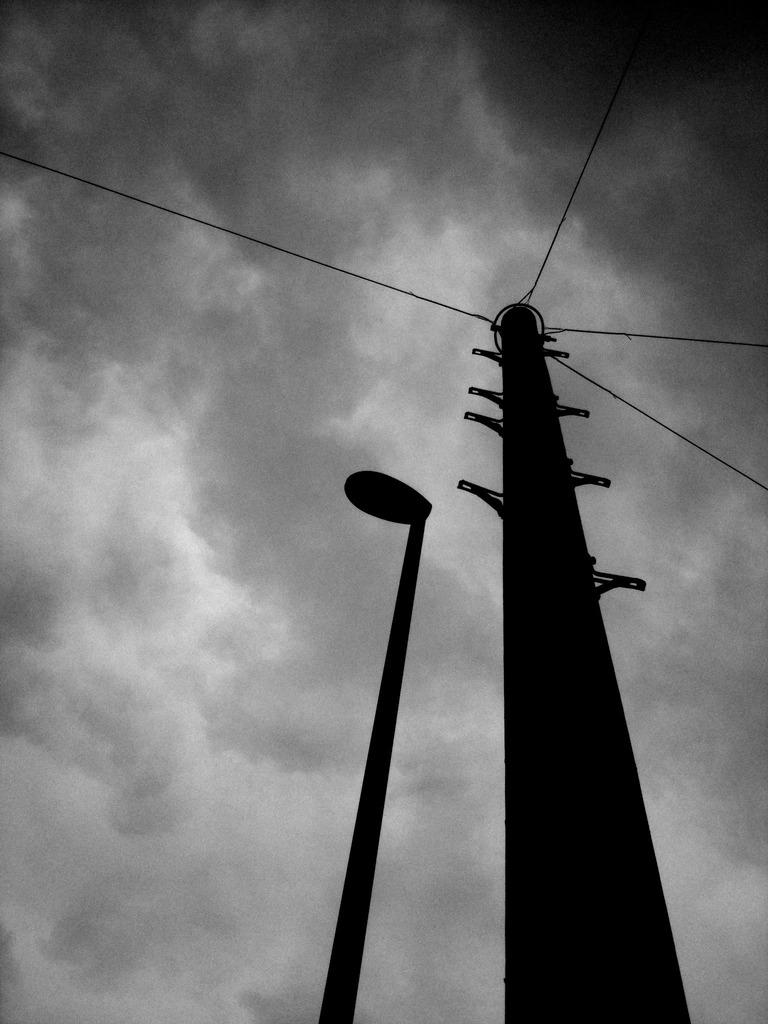What structure can be seen in the image that is related to electricity? There is an electric pole in the image. What is connected to the electric pole? There are wires connected to the electric pole. What other type of pole is present in the image? There is a street light pole in the image. What can be seen in the background of the image? The sky is visible in the background of the image. What type of treatment is being administered to the engine in the image? There is no engine present in the image, so no treatment can be administered to it. How many toes are visible on the street light pole in the image? There are no toes present in the image, as it features an electric pole, wires, and a street light pole. 